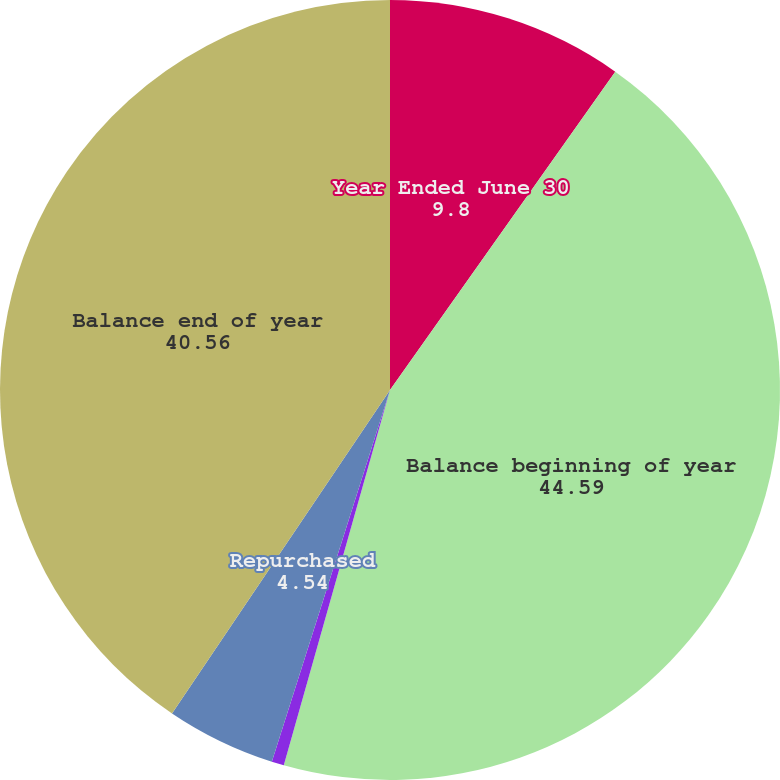<chart> <loc_0><loc_0><loc_500><loc_500><pie_chart><fcel>Year Ended June 30<fcel>Balance beginning of year<fcel>Issued<fcel>Repurchased<fcel>Balance end of year<nl><fcel>9.8%<fcel>44.59%<fcel>0.51%<fcel>4.54%<fcel>40.56%<nl></chart> 